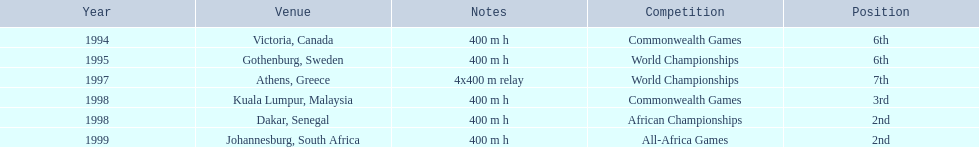What country was the 1997 championships held in? Athens, Greece. What long was the relay? 4x400 m relay. 